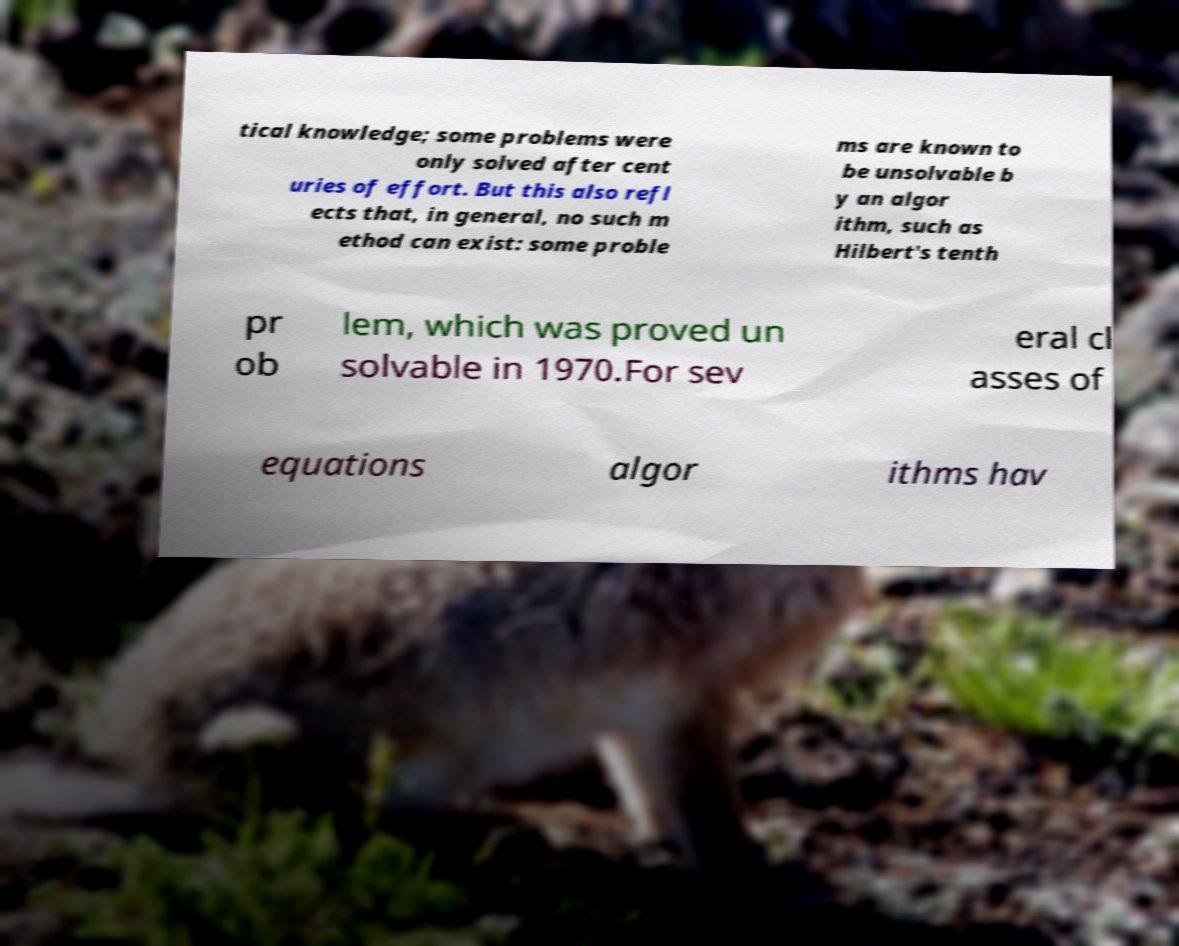Could you assist in decoding the text presented in this image and type it out clearly? tical knowledge; some problems were only solved after cent uries of effort. But this also refl ects that, in general, no such m ethod can exist: some proble ms are known to be unsolvable b y an algor ithm, such as Hilbert's tenth pr ob lem, which was proved un solvable in 1970.For sev eral cl asses of equations algor ithms hav 